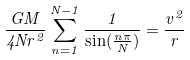<formula> <loc_0><loc_0><loc_500><loc_500>\frac { G M } { 4 N r ^ { 2 } } \sum _ { n = 1 } ^ { N - 1 } \frac { 1 } { \sin ( \frac { n \pi } { N } ) } = \frac { v ^ { 2 } } { r }</formula> 